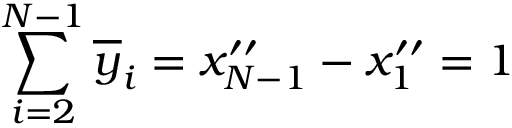Convert formula to latex. <formula><loc_0><loc_0><loc_500><loc_500>\sum _ { i = 2 } ^ { N - 1 } \overline { y } _ { i } = x _ { N - 1 } ^ { \prime \prime } - x _ { 1 } ^ { \prime \prime } = 1</formula> 